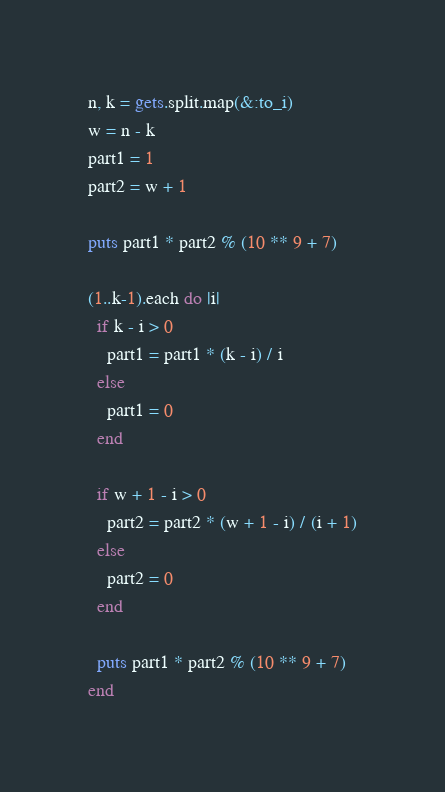Convert code to text. <code><loc_0><loc_0><loc_500><loc_500><_Ruby_>n, k = gets.split.map(&:to_i)
w = n - k
part1 = 1
part2 = w + 1

puts part1 * part2 % (10 ** 9 + 7)

(1..k-1).each do |i|
  if k - i > 0
    part1 = part1 * (k - i) / i
  else
    part1 = 0
  end

  if w + 1 - i > 0
    part2 = part2 * (w + 1 - i) / (i + 1)
  else
    part2 = 0
  end

  puts part1 * part2 % (10 ** 9 + 7)
end</code> 